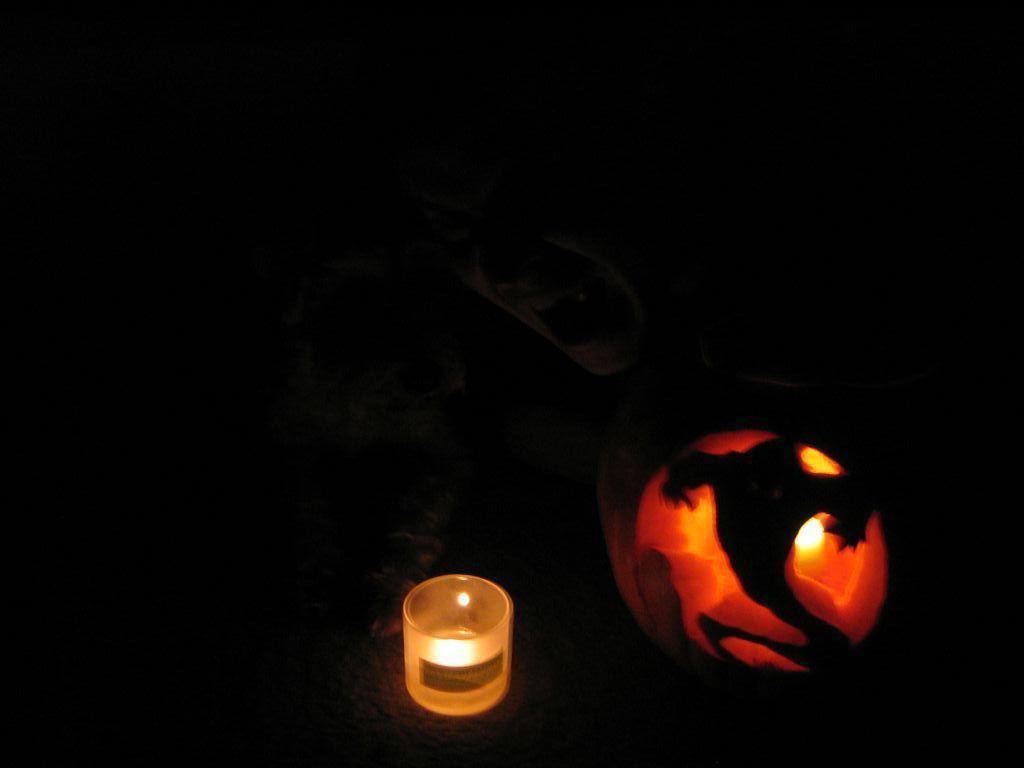How would you summarize this image in a sentence or two? In the image I can see a candle and some other things. The background of the image is dark. 